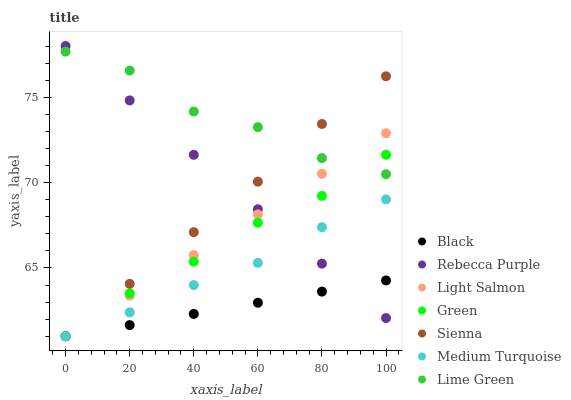Does Black have the minimum area under the curve?
Answer yes or no. Yes. Does Lime Green have the maximum area under the curve?
Answer yes or no. Yes. Does Sienna have the minimum area under the curve?
Answer yes or no. No. Does Sienna have the maximum area under the curve?
Answer yes or no. No. Is Light Salmon the smoothest?
Answer yes or no. Yes. Is Lime Green the roughest?
Answer yes or no. Yes. Is Sienna the smoothest?
Answer yes or no. No. Is Sienna the roughest?
Answer yes or no. No. Does Light Salmon have the lowest value?
Answer yes or no. Yes. Does Rebecca Purple have the lowest value?
Answer yes or no. No. Does Rebecca Purple have the highest value?
Answer yes or no. Yes. Does Sienna have the highest value?
Answer yes or no. No. Is Medium Turquoise less than Lime Green?
Answer yes or no. Yes. Is Lime Green greater than Medium Turquoise?
Answer yes or no. Yes. Does Green intersect Lime Green?
Answer yes or no. Yes. Is Green less than Lime Green?
Answer yes or no. No. Is Green greater than Lime Green?
Answer yes or no. No. Does Medium Turquoise intersect Lime Green?
Answer yes or no. No. 